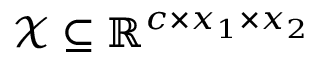<formula> <loc_0><loc_0><loc_500><loc_500>\mathcal { X } \subseteq \mathbb { R } ^ { c \times x _ { 1 } \times x _ { 2 } }</formula> 